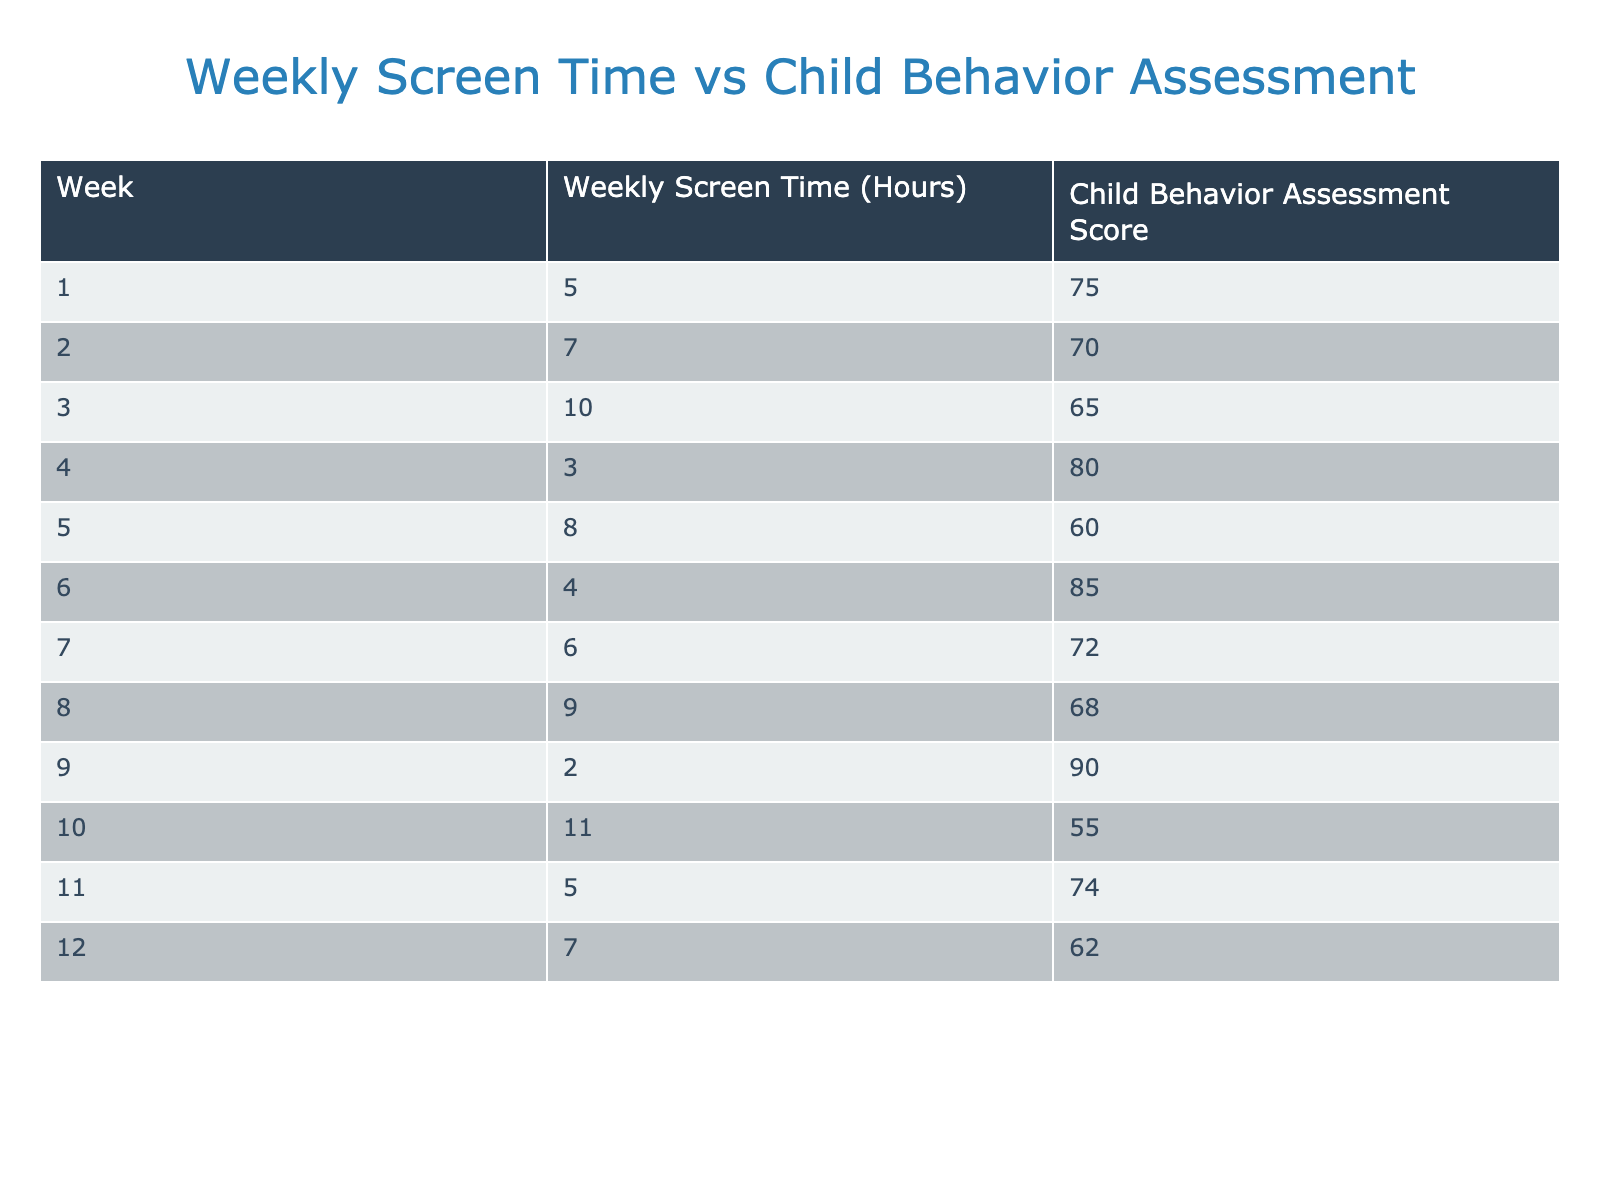What was the highest child behavior assessment score recorded? The maximum value for the "Child Behavior Assessment Score" in the table occurs in Week 9, where the score is 90. After reviewing all the scores from each week, it is evident that 90 is the highest.
Answer: 90 What was the weekly screen time for Week 5? The table shows that the "Weekly Screen Time" for Week 5 is listed as 8 hours. This is directly taken from the relevant row in the table.
Answer: 8 hours What is the average weekly screen time over the 12 weeks? To find the average, first sum the weekly screen times: (5 + 7 + 10 + 3 + 8 + 4 + 6 + 9 + 2 + 11 + 5 + 7) = 66 hours. Then divide by the number of weeks: 66/12 = 5.5 hours per week.
Answer: 5.5 hours Did the child behavior assessment score improve during Week 3 compared to Week 2? Week 2 had a score of 70, while Week 3's score was 65. Since 65 is lower than 70, the score did not improve. Therefore, the answer is no.
Answer: No What was the total decrease in child behavior assessment scores from Week 1 to Week 10? Week 1 has a score of 75, and Week 10 has a score of 55. To find the decrease, subtract the score of Week 10 from that of Week 1: 75 - 55 = 20. Thus, the total decrease is 20 points.
Answer: 20 points Is there any week where the screen time was less than the average weekly screen time of 5.5 hours? Looking at the screen time data, Week 4 had only 3 hours, and Week 9 had 2 hours, both are less than 5.5. Therefore, the answer to whether any weeks had less than average screen time is yes.
Answer: Yes What is the child behavior assessment score difference between Week 6 and Week 4? Week 6 has a score of 85, while Week 4 has a score of 80. The difference is calculated as follows: 85 - 80 = 5. Thus, the score difference is 5 points.
Answer: 5 points Was the average child behavior score across the weeks higher than 70? To calculate the average, first sum all scores: (75 + 70 + 65 + 80 + 60 + 85 + 72 + 68 + 90 + 55 + 74 + 62) = 885. Then divide by the number of weeks: 885/12 = 73.75, which is higher than 70. Therefore, the answer is yes.
Answer: Yes 